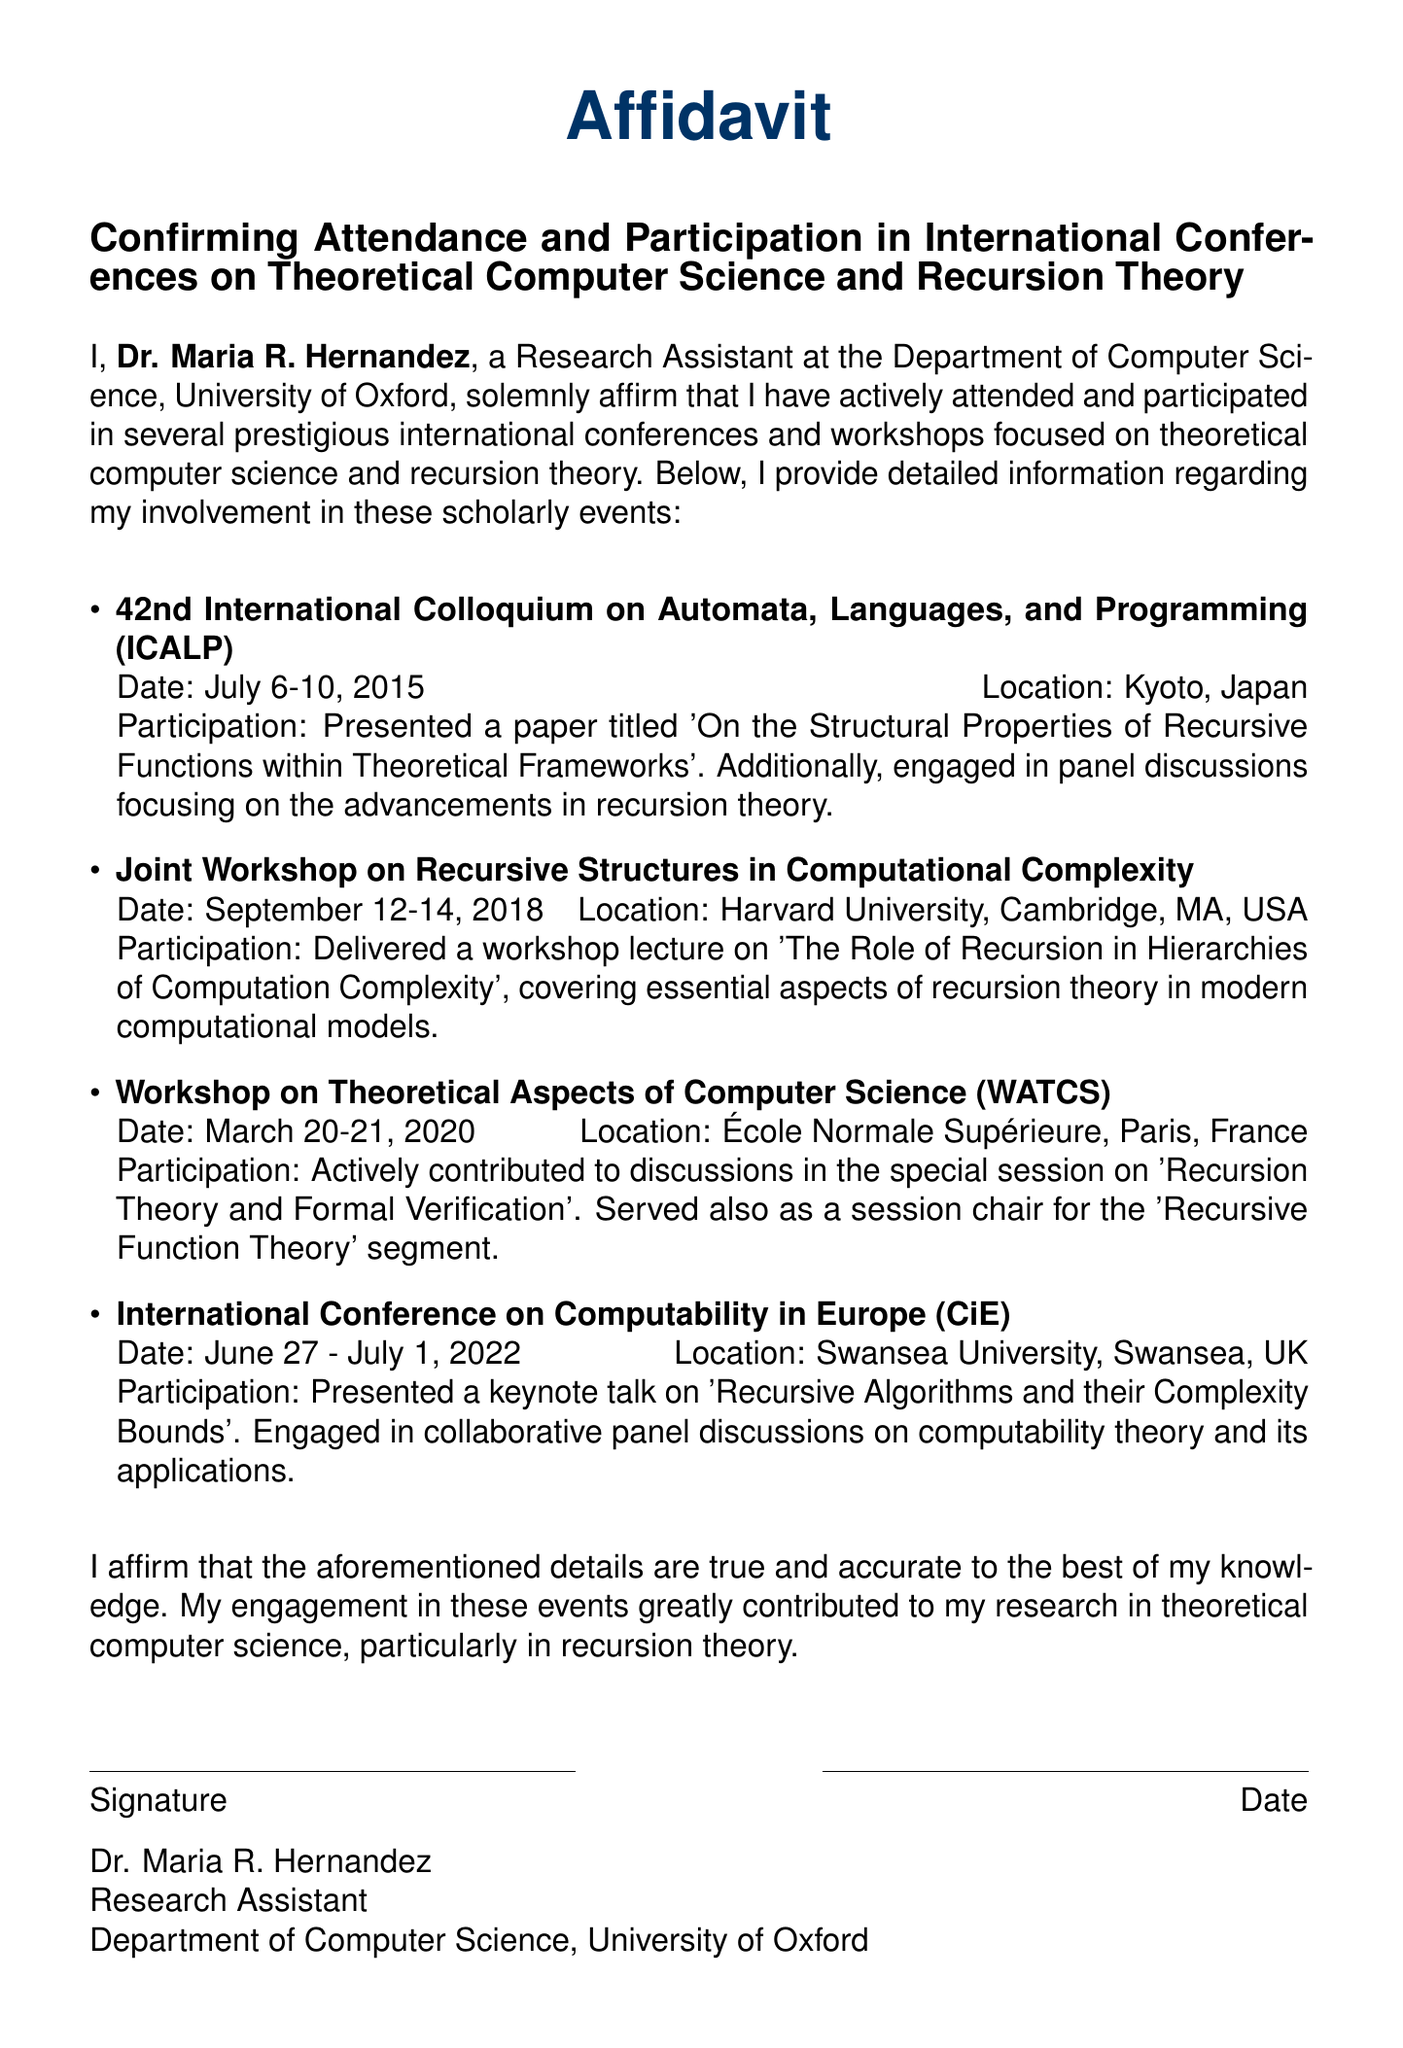What is the name of the researcher? The researcher is Dr. Maria R. Hernandez, as stated in the document.
Answer: Dr. Maria R. Hernandez What was the date of the ICALP conference? The ICALP conference took place from July 6-10, 2015, as mentioned in the document.
Answer: July 6-10, 2015 Where was the Joint Workshop on Recursive Structures held? The Joint Workshop on Recursive Structures was held at Harvard University, Cambridge, MA, USA, according to the document.
Answer: Harvard University, Cambridge, MA, USA What title did Dr. Hernandez present at the CiE conference? Dr. Hernandez presented the keynote talk titled 'Recursive Algorithms and their Complexity Bounds' at the CiE conference.
Answer: Recursive Algorithms and their Complexity Bounds Which event did Dr. Hernandez chair a session? Dr. Hernandez served as a session chair for the 'Recursive Function Theory' segment during the WATCS event.
Answer: WATCS What was the main topic discussed at the workshop lecture given by Dr. Hernandez? The main topic discussed was 'The Role of Recursion in Hierarchies of Computation Complexity', as stated in the document.
Answer: The Role of Recursion in Hierarchies of Computation Complexity What is the purpose of this affidavit? The purpose of the affidavit is to confirm attendance and participation in international conferences on theoretical computer science and recursion theory.
Answer: Confirming Attendance and Participation How many events are listed in the affidavit? The affidavit lists four events where Dr. Hernandez participated.
Answer: Four events What is Dr. Hernandez's position? Dr. Hernandez is a Research Assistant, as indicated in the document.
Answer: Research Assistant 